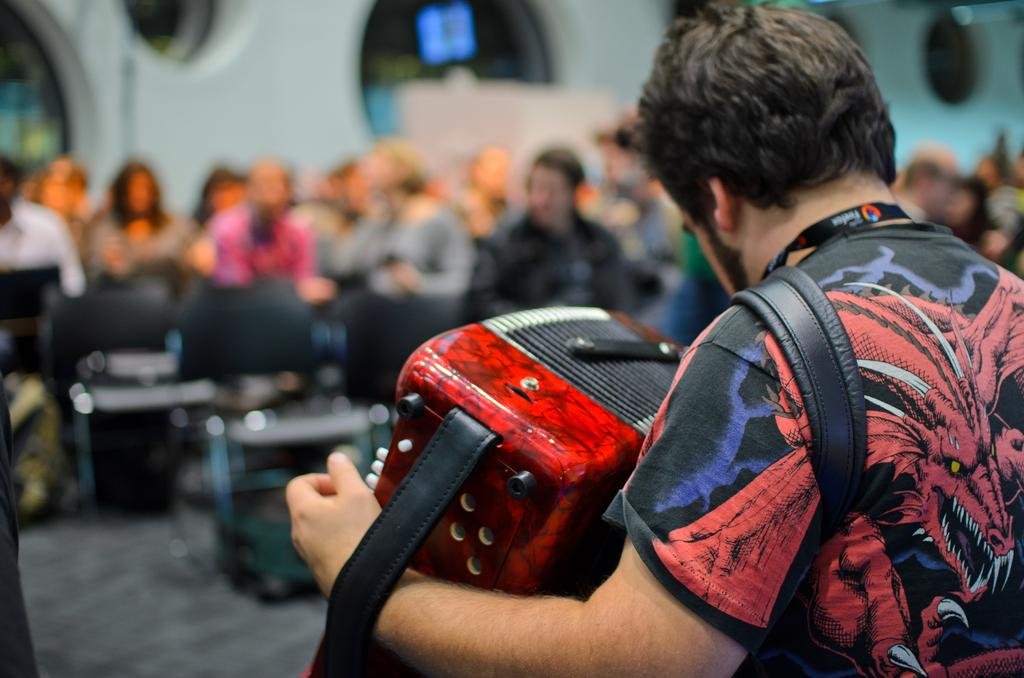What is the person in the image holding? The person is holding an accordion. What is the person doing with the accordion? The person is playing the accordion. Can you describe the background of the image? The background is blurred. Are there any other people visible in the image? Yes, there are people in the background. What type of robin can be seen singing in the background of the image? There is no robin present in the image; the background is blurred and does not show any birds or animals. 